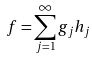<formula> <loc_0><loc_0><loc_500><loc_500>f = \sum _ { j = 1 } ^ { \infty } g _ { j } h _ { j }</formula> 